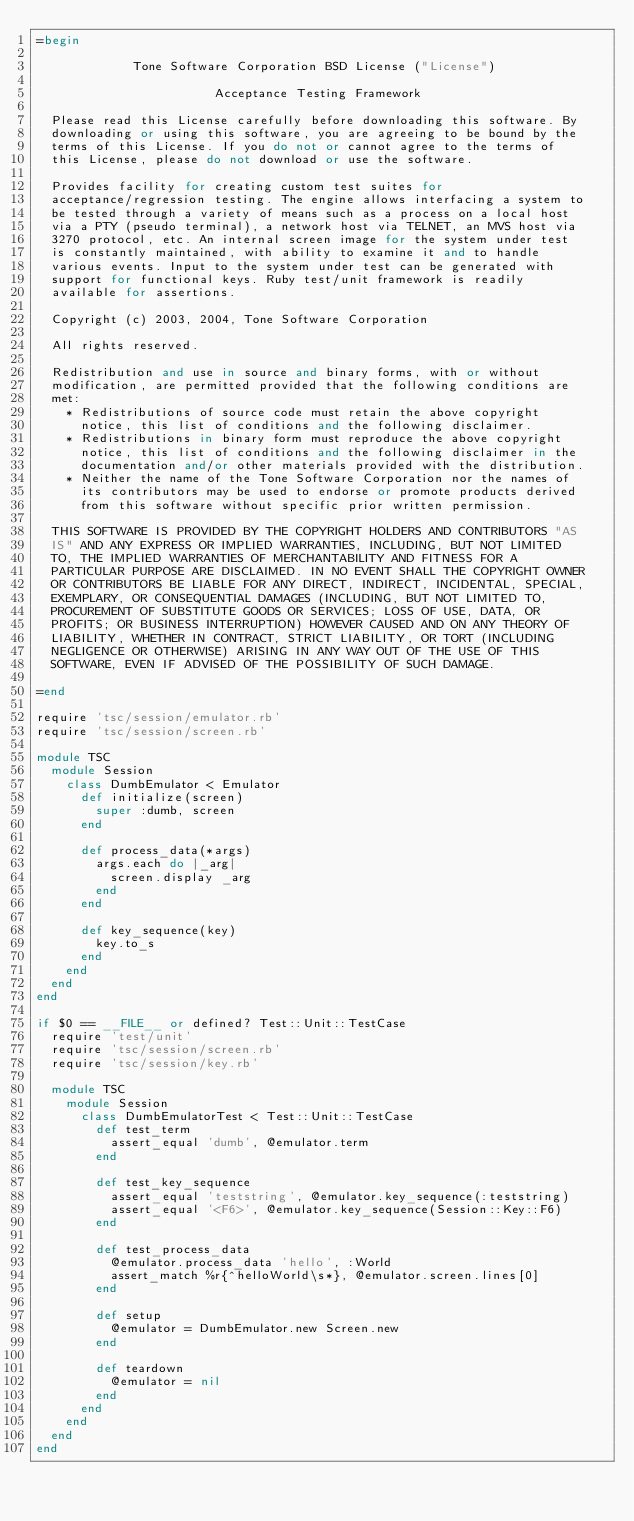<code> <loc_0><loc_0><loc_500><loc_500><_Ruby_>=begin
 
             Tone Software Corporation BSD License ("License")
  
                        Acceptance Testing Framework
  
  Please read this License carefully before downloading this software. By
  downloading or using this software, you are agreeing to be bound by the
  terms of this License. If you do not or cannot agree to the terms of
  this License, please do not download or use the software.
  
  Provides facility for creating custom test suites for
  acceptance/regression testing. The engine allows interfacing a system to
  be tested through a variety of means such as a process on a local host
  via a PTY (pseudo terminal), a network host via TELNET, an MVS host via
  3270 protocol, etc. An internal screen image for the system under test
  is constantly maintained, with ability to examine it and to handle
  various events. Input to the system under test can be generated with
  support for functional keys. Ruby test/unit framework is readily
  available for assertions.
       
  Copyright (c) 2003, 2004, Tone Software Corporation
       
  All rights reserved.
       
  Redistribution and use in source and binary forms, with or without
  modification, are permitted provided that the following conditions are
  met:
    * Redistributions of source code must retain the above copyright
      notice, this list of conditions and the following disclaimer. 
    * Redistributions in binary form must reproduce the above copyright
      notice, this list of conditions and the following disclaimer in the
      documentation and/or other materials provided with the distribution. 
    * Neither the name of the Tone Software Corporation nor the names of
      its contributors may be used to endorse or promote products derived
      from this software without specific prior written permission. 
  
  THIS SOFTWARE IS PROVIDED BY THE COPYRIGHT HOLDERS AND CONTRIBUTORS "AS
  IS" AND ANY EXPRESS OR IMPLIED WARRANTIES, INCLUDING, BUT NOT LIMITED
  TO, THE IMPLIED WARRANTIES OF MERCHANTABILITY AND FITNESS FOR A
  PARTICULAR PURPOSE ARE DISCLAIMED. IN NO EVENT SHALL THE COPYRIGHT OWNER
  OR CONTRIBUTORS BE LIABLE FOR ANY DIRECT, INDIRECT, INCIDENTAL, SPECIAL,
  EXEMPLARY, OR CONSEQUENTIAL DAMAGES (INCLUDING, BUT NOT LIMITED TO,
  PROCUREMENT OF SUBSTITUTE GOODS OR SERVICES; LOSS OF USE, DATA, OR
  PROFITS; OR BUSINESS INTERRUPTION) HOWEVER CAUSED AND ON ANY THEORY OF
  LIABILITY, WHETHER IN CONTRACT, STRICT LIABILITY, OR TORT (INCLUDING
  NEGLIGENCE OR OTHERWISE) ARISING IN ANY WAY OUT OF THE USE OF THIS
  SOFTWARE, EVEN IF ADVISED OF THE POSSIBILITY OF SUCH DAMAGE.
  
=end

require 'tsc/session/emulator.rb'
require 'tsc/session/screen.rb'

module TSC
  module Session
    class DumbEmulator < Emulator
      def initialize(screen)
        super :dumb, screen
      end

      def process_data(*args)
        args.each do |_arg|
          screen.display _arg
        end
      end

      def key_sequence(key)
        key.to_s
      end
    end
  end
end

if $0 == __FILE__ or defined? Test::Unit::TestCase
  require 'test/unit'
  require 'tsc/session/screen.rb'
  require 'tsc/session/key.rb'

  module TSC
    module Session
      class DumbEmulatorTest < Test::Unit::TestCase
        def test_term
          assert_equal 'dumb', @emulator.term
        end

        def test_key_sequence
          assert_equal 'teststring', @emulator.key_sequence(:teststring)
          assert_equal '<F6>', @emulator.key_sequence(Session::Key::F6)
        end

        def test_process_data
          @emulator.process_data 'hello', :World
          assert_match %r{^helloWorld\s*}, @emulator.screen.lines[0]
        end

        def setup
          @emulator = DumbEmulator.new Screen.new
        end

        def teardown
          @emulator = nil
        end
      end
    end
  end
end
</code> 